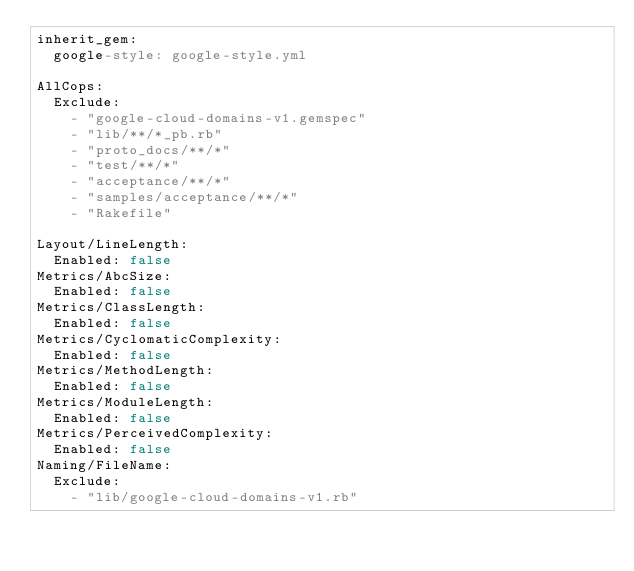<code> <loc_0><loc_0><loc_500><loc_500><_YAML_>inherit_gem:
  google-style: google-style.yml

AllCops:
  Exclude:
    - "google-cloud-domains-v1.gemspec"
    - "lib/**/*_pb.rb"
    - "proto_docs/**/*"
    - "test/**/*"
    - "acceptance/**/*"
    - "samples/acceptance/**/*"
    - "Rakefile"

Layout/LineLength:
  Enabled: false
Metrics/AbcSize:
  Enabled: false
Metrics/ClassLength:
  Enabled: false
Metrics/CyclomaticComplexity:
  Enabled: false
Metrics/MethodLength:
  Enabled: false
Metrics/ModuleLength:
  Enabled: false
Metrics/PerceivedComplexity:
  Enabled: false
Naming/FileName:
  Exclude:
    - "lib/google-cloud-domains-v1.rb"
</code> 